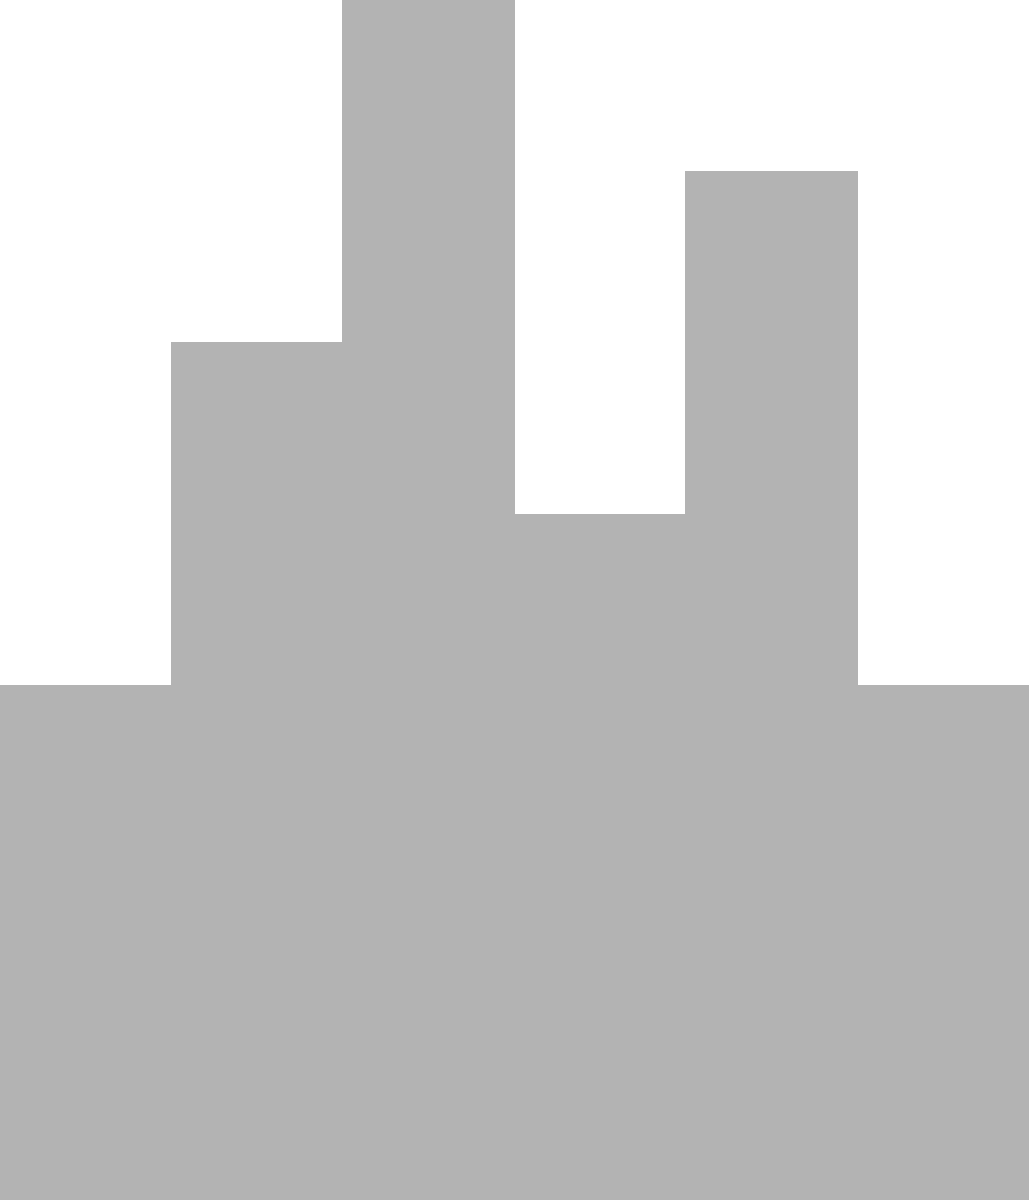Consider the urban air quality model depicted in the image. If the wind speed doubles and all other factors remain constant, how would this change affect the concentration of pollutants at ground level in the downtown area (center of the skyline)?

A) Increase significantly
B) Decrease significantly
C) Remain approximately the same
D) Increase slightly To answer this question, we need to consider the principles of pollution dispersion in urban environments:

1. Wind speed is a crucial factor in pollution dispersion models.

2. The basic Gaussian plume model for pollution dispersion is given by:

   $$C(x,y,z) = \frac{Q}{2\pi u \sigma_y \sigma_z} \exp\left(-\frac{y^2}{2\sigma_y^2}\right) \left[\exp\left(-\frac{(z-H)^2}{2\sigma_z^2}\right) + \exp\left(-\frac{(z+H)^2}{2\sigma_z^2}\right)\right]$$

   where $C$ is the concentration, $Q$ is the emission rate, $u$ is the wind speed, and $\sigma_y$ and $\sigma_z$ are dispersion coefficients.

3. From this equation, we can see that concentration $C$ is inversely proportional to wind speed $u$.

4. When wind speed doubles, keeping all other factors constant:

   $$C_{\text{new}} = \frac{C_{\text{old}}}{2}$$

5. This means that doubling the wind speed will halve the concentration of pollutants at any given point.

6. In the context of the urban environment shown in the image, increased wind speed will lead to:
   - More rapid dispersion of pollutants
   - Lower retention time of pollutants in the urban area
   - Reduced accumulation of pollutants in street canyons

7. The effect will be most pronounced in the downtown area (center of the skyline) where buildings create complex air flow patterns.

Therefore, doubling the wind speed will significantly decrease the concentration of pollutants at ground level in the downtown area.
Answer: B) Decrease significantly 